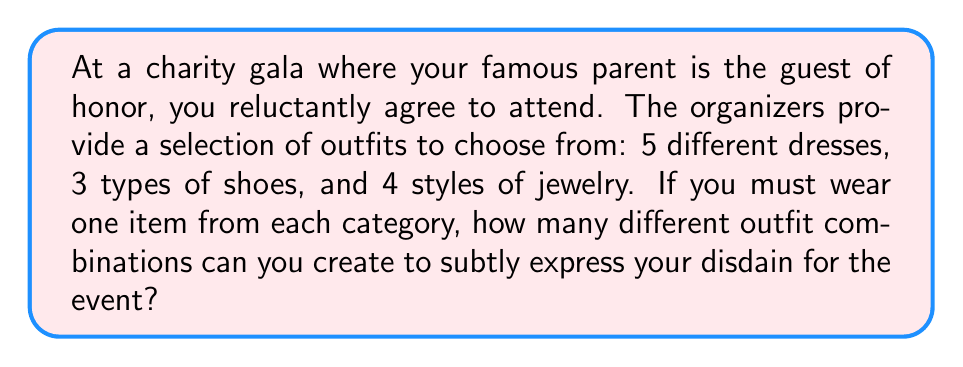Help me with this question. Let's approach this step-by-step:

1) We are dealing with a combination problem where we need to select one item from each category.

2) The number of choices for each category are:
   - Dresses: 5
   - Shoes: 3
   - Jewelry: 4

3) When we need to make multiple independent choices, we multiply the number of options for each choice. This is known as the Multiplication Principle.

4) Therefore, the total number of possible outfit combinations is:

   $$ \text{Total combinations} = \text{Dresses} \times \text{Shoes} \times \text{Jewelry} $$

5) Substituting the values:

   $$ \text{Total combinations} = 5 \times 3 \times 4 $$

6) Calculating:

   $$ \text{Total combinations} = 60 $$

Thus, there are 60 different outfit combinations you can create for the charity gala.
Answer: 60 